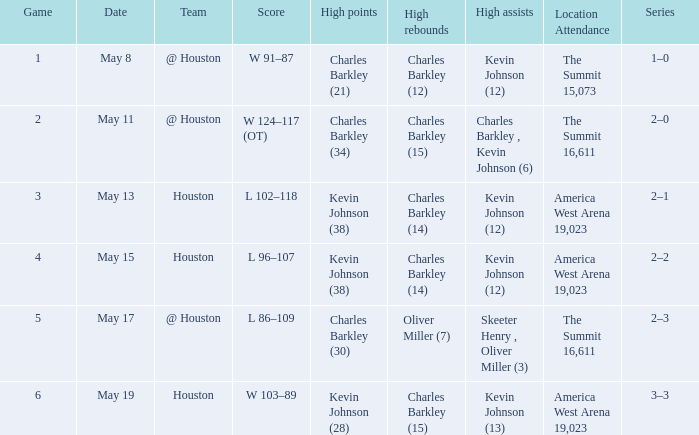Who did the high points in game number 1? Charles Barkley (21). 